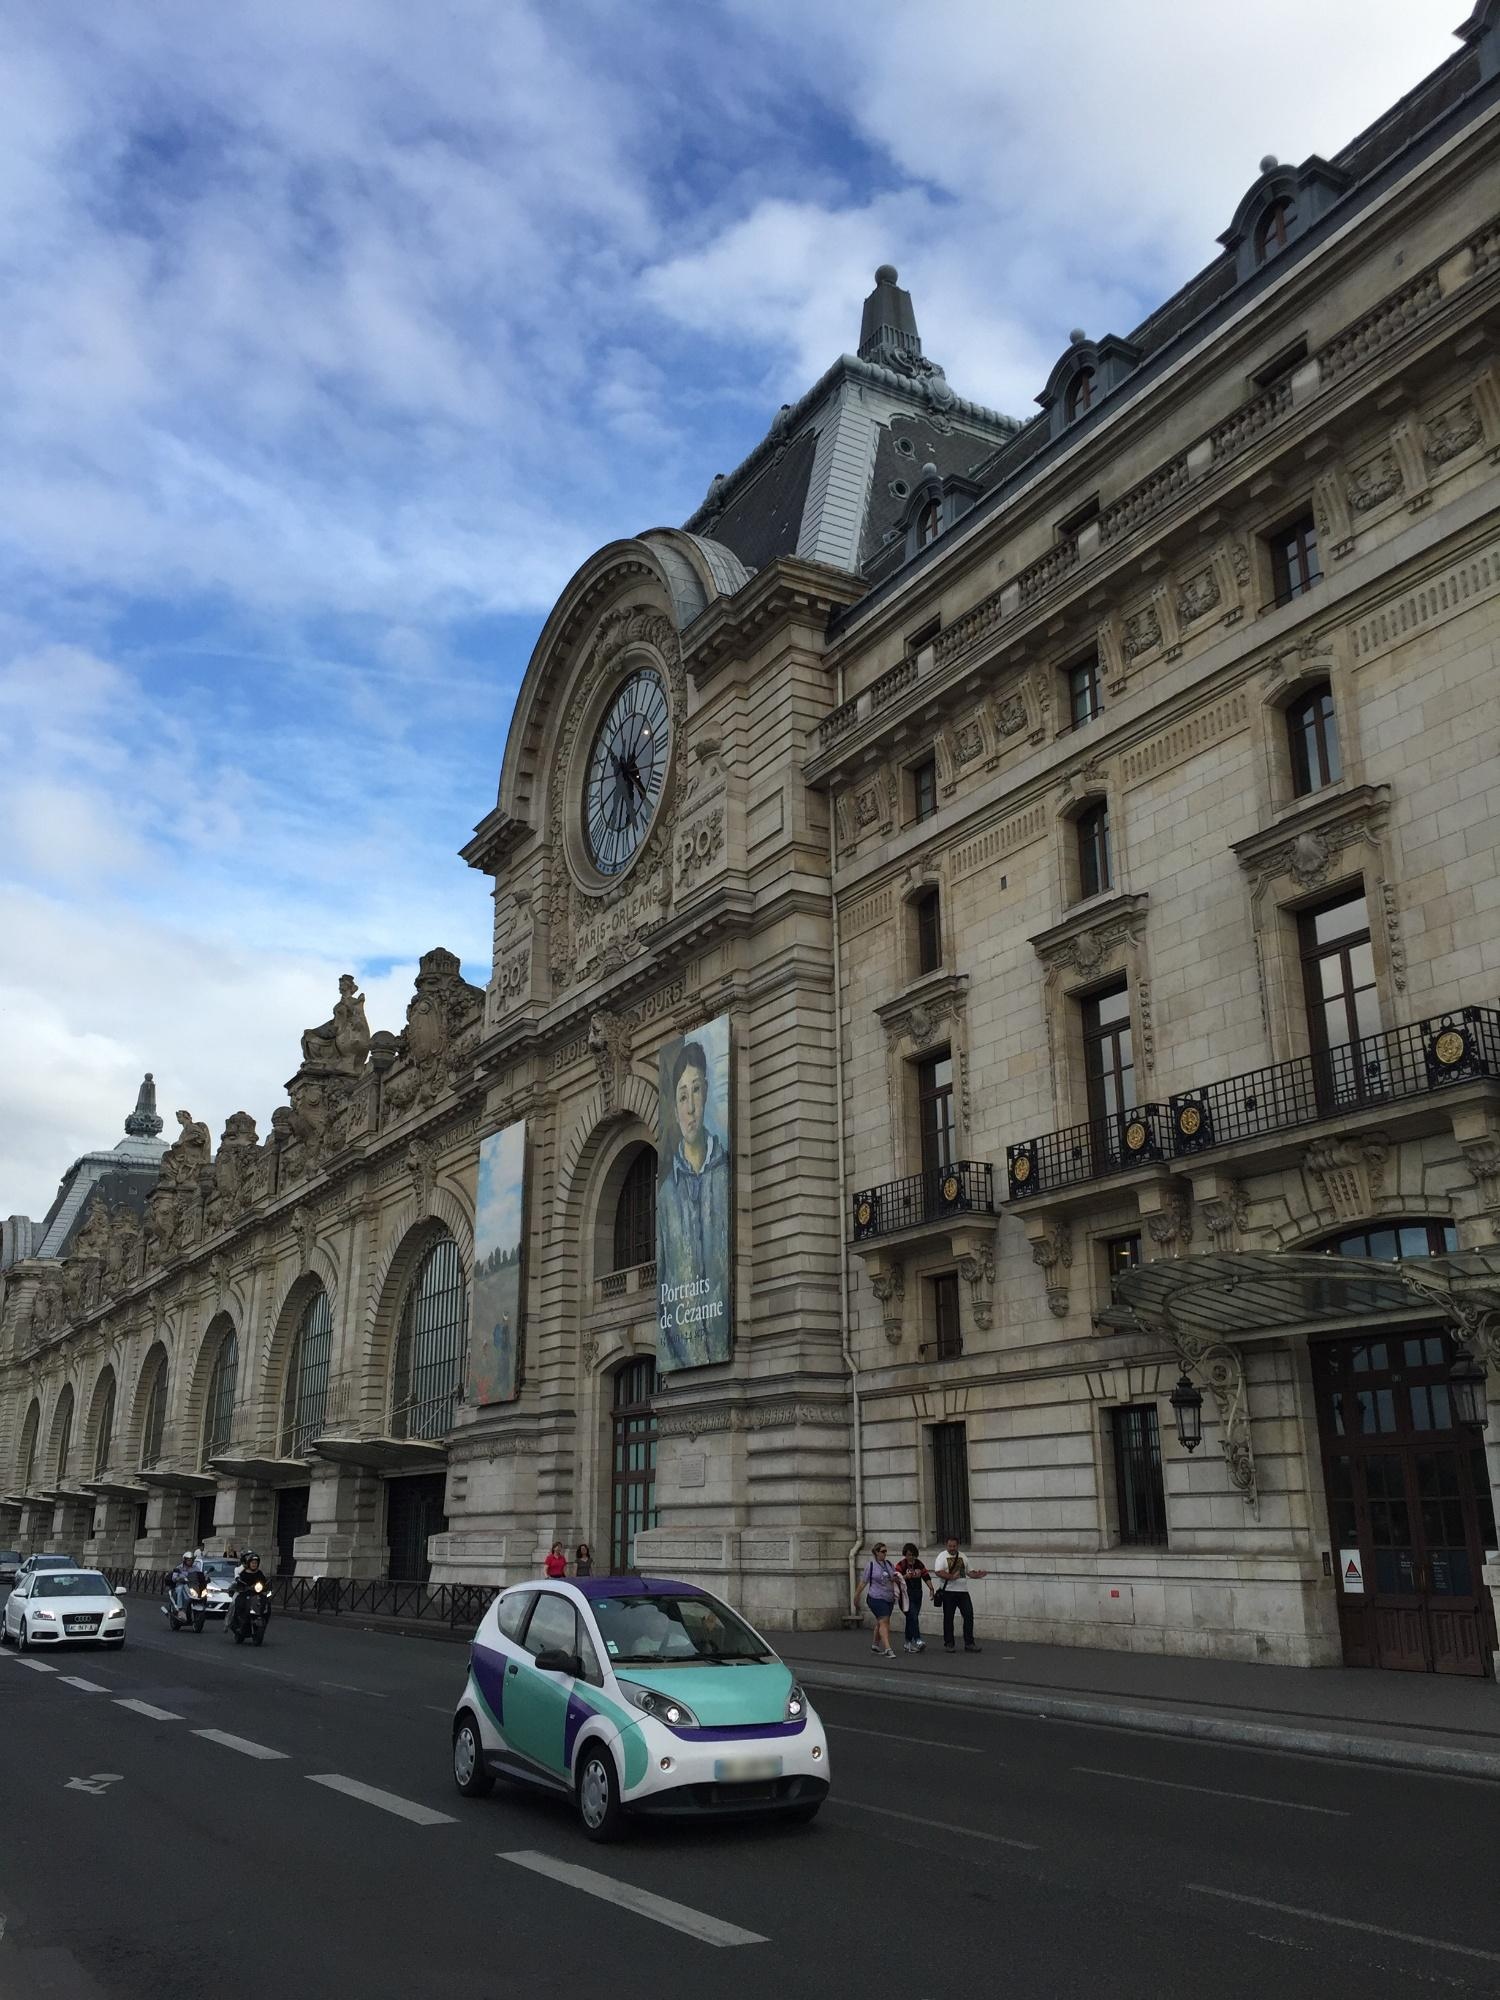What are the key elements in this picture?
 The image captures the grandeur of the Musée d'Orsay, a renowned landmark located in Paris, France. The museum, a former railway station, stands majestically against the backdrop of the cityscape. Its architecture, characterized by light-colored stone, exudes a sense of history and elegance. Dominating the facade is a large clock, a reminder of the building's past life. The street in front of the museum is bustling with activity, with several cars and people adding life to the scene. The perspective from which the photo is taken offers a comprehensive view of the museum, placing it in the context of its urban surroundings. The identifier "sa_17801" could potentially be a reference to a specific collection or exhibit within the museum. 